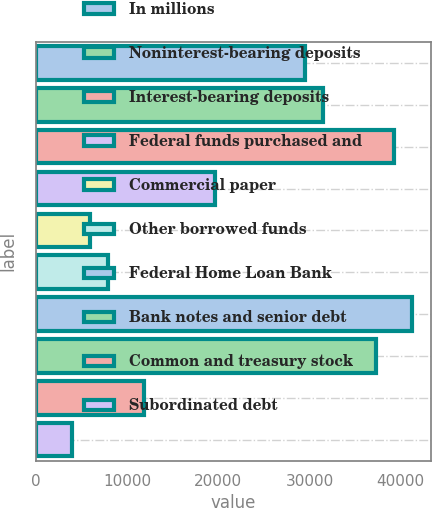Convert chart. <chart><loc_0><loc_0><loc_500><loc_500><bar_chart><fcel>In millions<fcel>Noninterest-bearing deposits<fcel>Interest-bearing deposits<fcel>Federal funds purchased and<fcel>Commercial paper<fcel>Other borrowed funds<fcel>Federal Home Loan Bank<fcel>Bank notes and senior debt<fcel>Common and treasury stock<fcel>Subordinated debt<nl><fcel>29473.5<fcel>31437.6<fcel>39294<fcel>19653<fcel>5904.3<fcel>7868.4<fcel>41258.1<fcel>37329.9<fcel>11796.6<fcel>3940.2<nl></chart> 